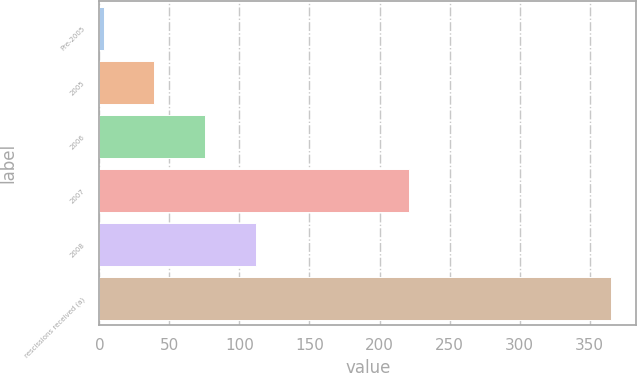Convert chart to OTSL. <chart><loc_0><loc_0><loc_500><loc_500><bar_chart><fcel>Pre-2005<fcel>2005<fcel>2006<fcel>2007<fcel>2008<fcel>rescissions received (a)<nl><fcel>3<fcel>39.2<fcel>75.4<fcel>221<fcel>111.6<fcel>365<nl></chart> 